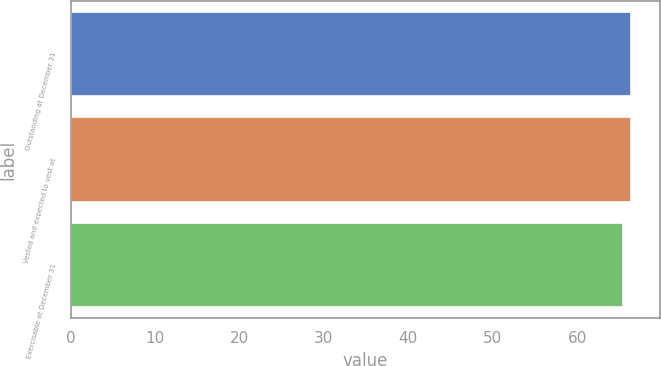Convert chart to OTSL. <chart><loc_0><loc_0><loc_500><loc_500><bar_chart><fcel>Outstanding at December 31<fcel>Vested and expected to vest at<fcel>Exercisable at December 31<nl><fcel>66.43<fcel>66.33<fcel>65.39<nl></chart> 